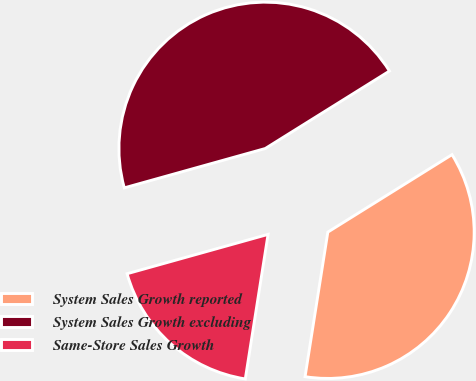<chart> <loc_0><loc_0><loc_500><loc_500><pie_chart><fcel>System Sales Growth reported<fcel>System Sales Growth excluding<fcel>Same-Store Sales Growth<nl><fcel>36.36%<fcel>45.45%<fcel>18.18%<nl></chart> 